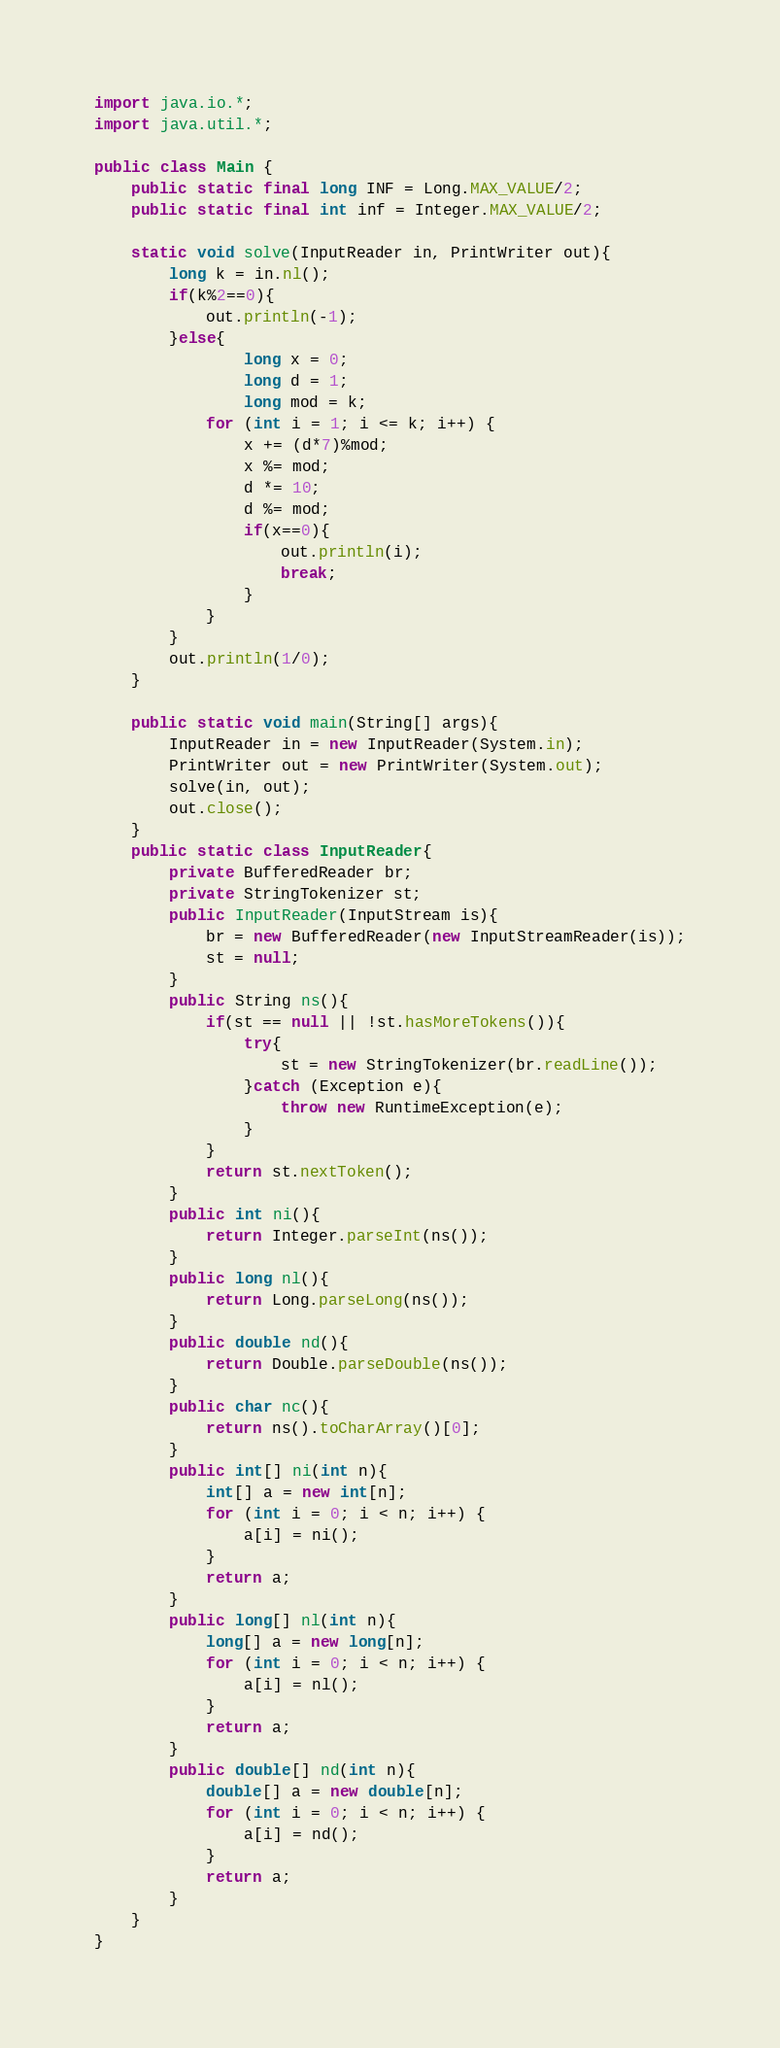<code> <loc_0><loc_0><loc_500><loc_500><_Java_>import java.io.*;
import java.util.*;

public class Main {
    public static final long INF = Long.MAX_VALUE/2;
    public static final int inf = Integer.MAX_VALUE/2;

    static void solve(InputReader in, PrintWriter out){
        long k = in.nl();
        if(k%2==0){
            out.println(-1);
        }else{
                long x = 0;
                long d = 1;
                long mod = k;
            for (int i = 1; i <= k; i++) {
                x += (d*7)%mod;
                x %= mod;
                d *= 10;
                d %= mod;
                if(x==0){
                    out.println(i);
                    break;
                }
            }
        }
        out.println(1/0);
    }

    public static void main(String[] args){
        InputReader in = new InputReader(System.in);
        PrintWriter out = new PrintWriter(System.out);
        solve(in, out);
        out.close();
    }
    public static class InputReader{
        private BufferedReader br;
        private StringTokenizer st;
        public InputReader(InputStream is){
            br = new BufferedReader(new InputStreamReader(is));
            st = null;
        }
        public String ns(){
            if(st == null || !st.hasMoreTokens()){
                try{
                    st = new StringTokenizer(br.readLine());
                }catch (Exception e){
                    throw new RuntimeException(e);
                }
            }
            return st.nextToken();
        }
        public int ni(){
            return Integer.parseInt(ns());
        }
        public long nl(){
            return Long.parseLong(ns());
        }
        public double nd(){
            return Double.parseDouble(ns());
        }
        public char nc(){
            return ns().toCharArray()[0];
        }
        public int[] ni(int n){
            int[] a = new int[n];
            for (int i = 0; i < n; i++) {
                a[i] = ni();
            }
            return a;
        }
        public long[] nl(int n){
            long[] a = new long[n];
            for (int i = 0; i < n; i++) {
                a[i] = nl();
            }
            return a;
        }
        public double[] nd(int n){
            double[] a = new double[n];
            for (int i = 0; i < n; i++) {
                a[i] = nd();
            }
            return a;
        }
    }
}</code> 